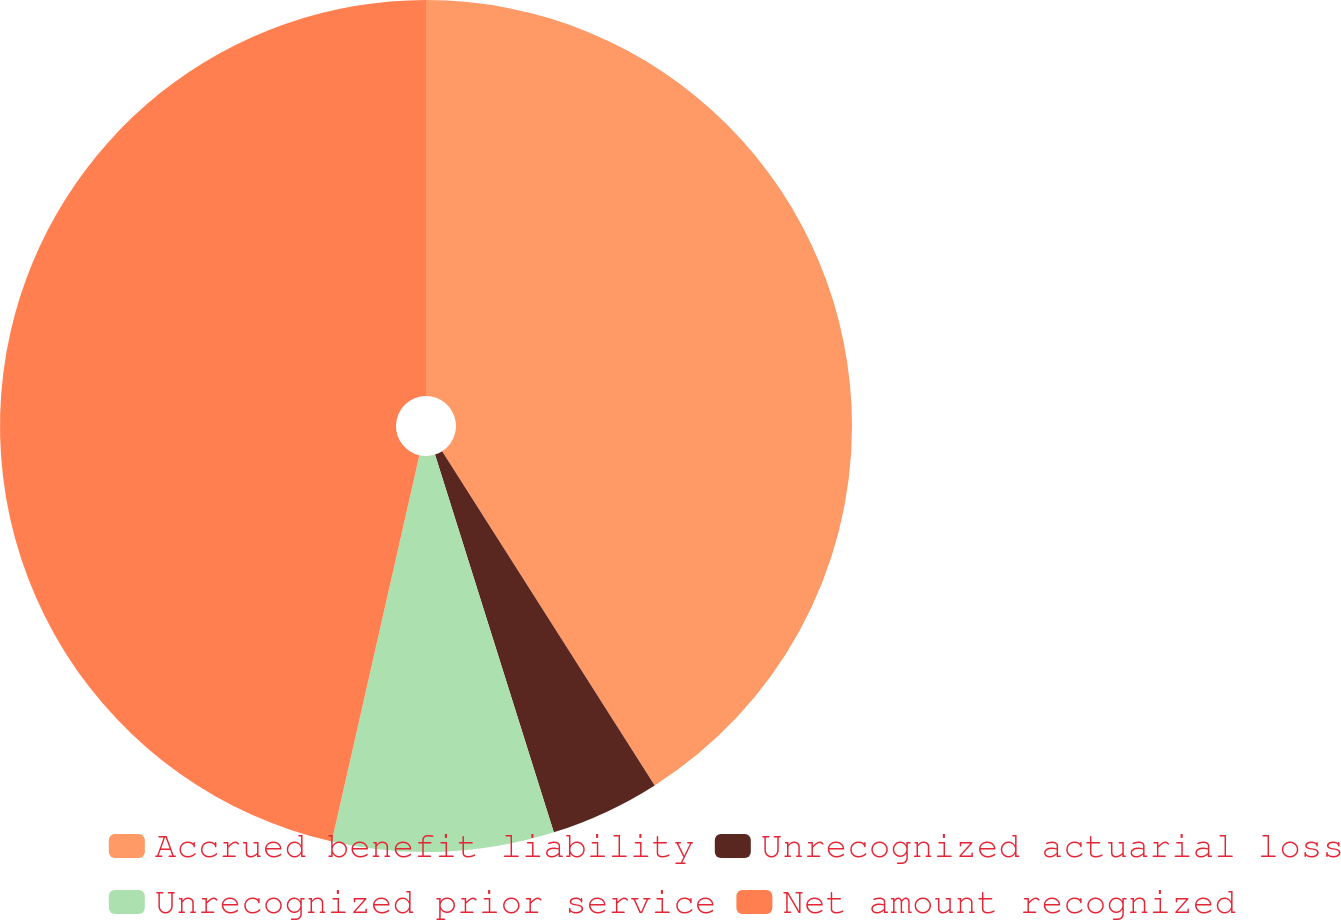Convert chart to OTSL. <chart><loc_0><loc_0><loc_500><loc_500><pie_chart><fcel>Accrued benefit liability<fcel>Unrecognized actuarial loss<fcel>Unrecognized prior service<fcel>Net amount recognized<nl><fcel>40.98%<fcel>4.17%<fcel>8.4%<fcel>46.45%<nl></chart> 